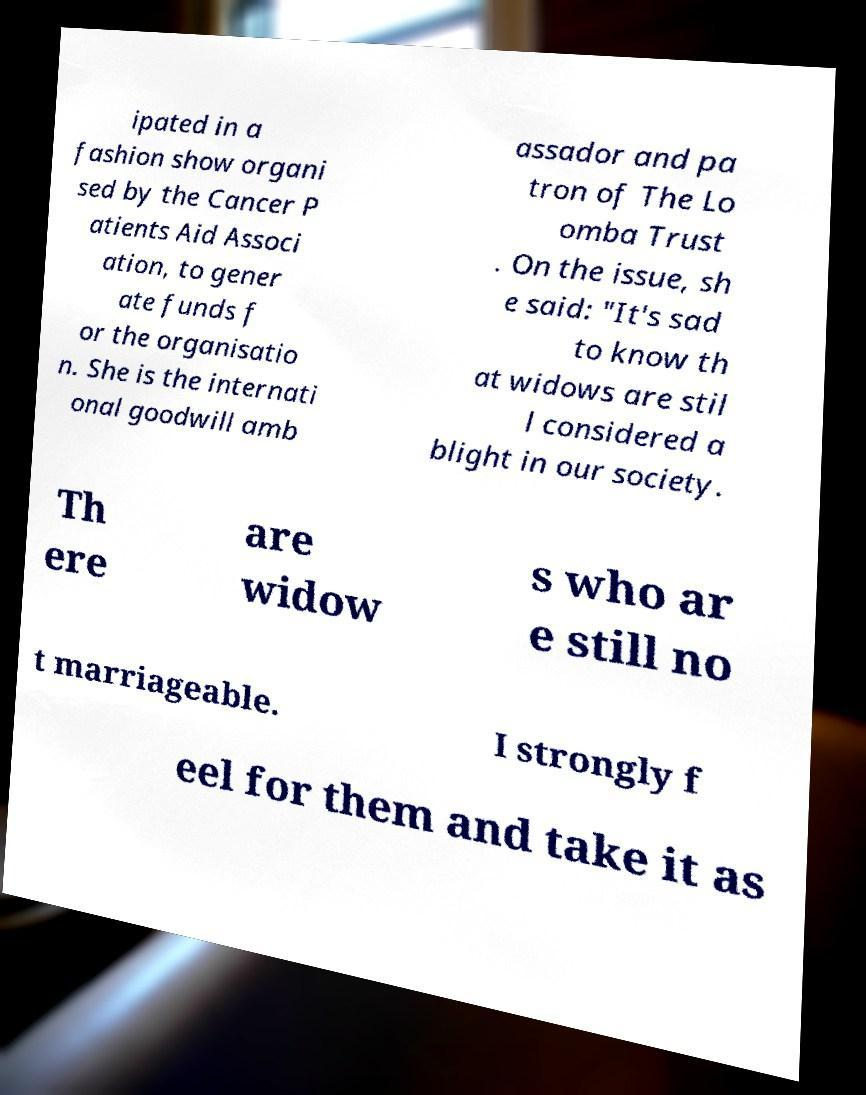Please identify and transcribe the text found in this image. ipated in a fashion show organi sed by the Cancer P atients Aid Associ ation, to gener ate funds f or the organisatio n. She is the internati onal goodwill amb assador and pa tron of The Lo omba Trust . On the issue, sh e said: "It's sad to know th at widows are stil l considered a blight in our society. Th ere are widow s who ar e still no t marriageable. I strongly f eel for them and take it as 